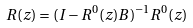Convert formula to latex. <formula><loc_0><loc_0><loc_500><loc_500>R ( z ) = ( I - R ^ { 0 } ( z ) B ) ^ { - 1 } R ^ { 0 } ( z )</formula> 